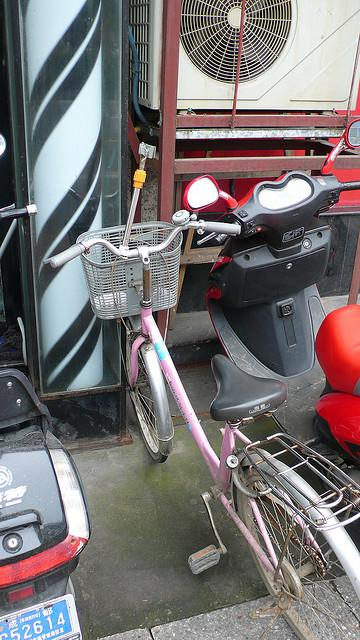What color is the frame of the girl's bike painted out to be? pink 